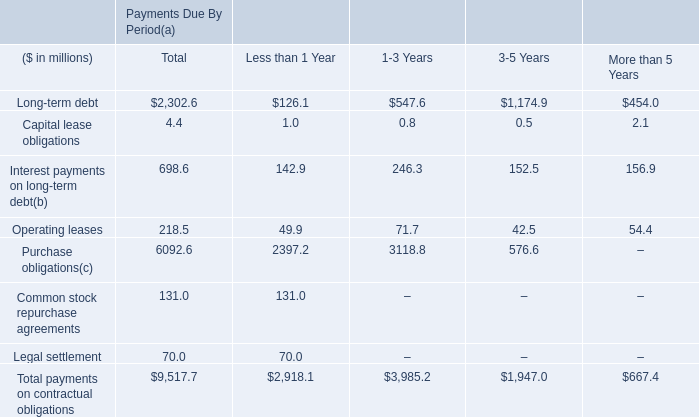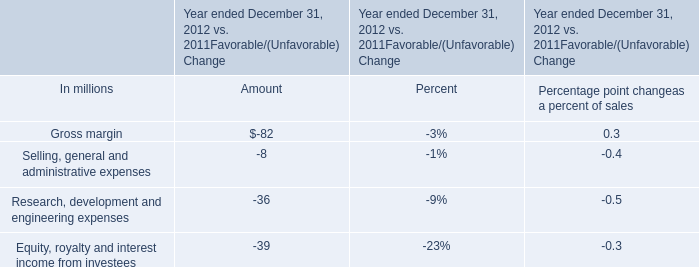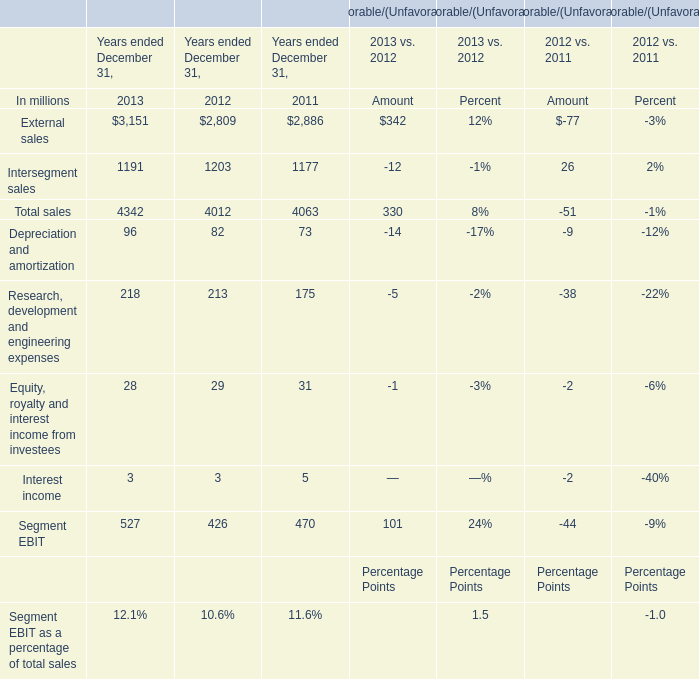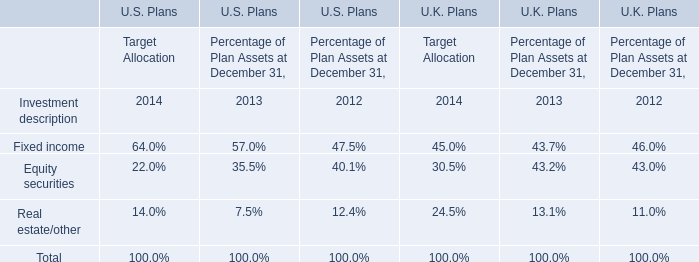If External sales develops with the same growth rate in 2013, what will it reach in 2014? (in dollars in millions) 
Computations: (3151 * (1 + ((3151 - 2809) / 2809)))
Answer: 3534.63902. 